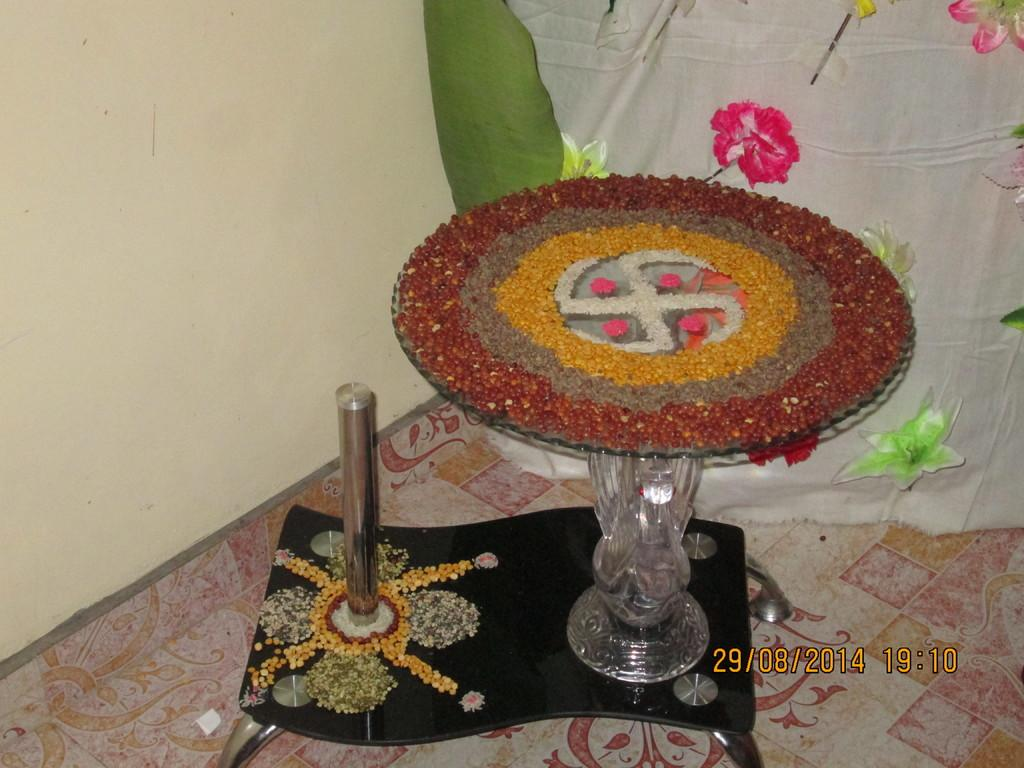What can be seen in the background of the image? There is a cloth in the background of the image. What type of furniture is present in the image? There is a table in the image. What is inside the glass that is visible in the image? There is a glass with pulses in the image. What is the main architectural feature in the image? There is a wall in the image. What type of plant material is present in the image? There is a leaf in the image. What type of silk is being used for breakfast in the image? There is no silk or breakfast present in the image. What type of plants are visible in the image? There are no plants visible in the image, only a leaf. 